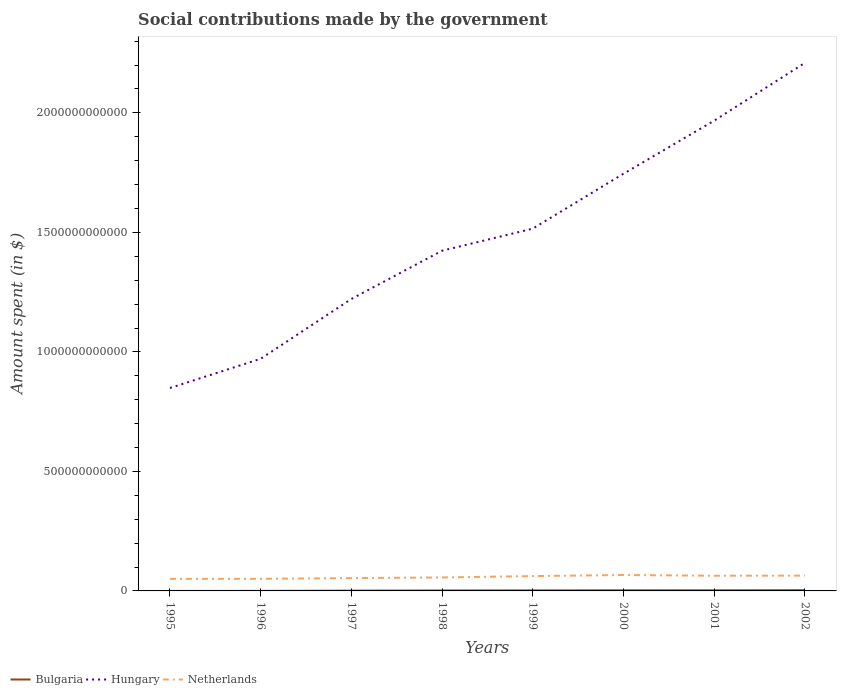How many different coloured lines are there?
Your answer should be very brief. 3. Is the number of lines equal to the number of legend labels?
Provide a succinct answer. Yes. Across all years, what is the maximum amount spent on social contributions in Netherlands?
Your response must be concise. 5.04e+1. What is the total amount spent on social contributions in Hungary in the graph?
Make the answer very short. -2.94e+11. What is the difference between the highest and the second highest amount spent on social contributions in Hungary?
Your answer should be compact. 1.36e+12. What is the difference between the highest and the lowest amount spent on social contributions in Hungary?
Your answer should be compact. 4. Is the amount spent on social contributions in Netherlands strictly greater than the amount spent on social contributions in Bulgaria over the years?
Provide a short and direct response. No. How many years are there in the graph?
Offer a very short reply. 8. What is the difference between two consecutive major ticks on the Y-axis?
Provide a short and direct response. 5.00e+11. Does the graph contain grids?
Your answer should be very brief. No. Where does the legend appear in the graph?
Give a very brief answer. Bottom left. How many legend labels are there?
Your answer should be compact. 3. How are the legend labels stacked?
Your response must be concise. Horizontal. What is the title of the graph?
Offer a very short reply. Social contributions made by the government. Does "Togo" appear as one of the legend labels in the graph?
Your answer should be compact. No. What is the label or title of the Y-axis?
Keep it short and to the point. Amount spent (in $). What is the Amount spent (in $) in Bulgaria in 1995?
Your response must be concise. 6.68e+07. What is the Amount spent (in $) of Hungary in 1995?
Your answer should be very brief. 8.49e+11. What is the Amount spent (in $) in Netherlands in 1995?
Offer a very short reply. 5.04e+1. What is the Amount spent (in $) of Bulgaria in 1996?
Make the answer very short. 1.18e+08. What is the Amount spent (in $) in Hungary in 1996?
Keep it short and to the point. 9.71e+11. What is the Amount spent (in $) in Netherlands in 1996?
Provide a succinct answer. 5.07e+1. What is the Amount spent (in $) in Bulgaria in 1997?
Offer a very short reply. 1.17e+09. What is the Amount spent (in $) of Hungary in 1997?
Make the answer very short. 1.22e+12. What is the Amount spent (in $) of Netherlands in 1997?
Make the answer very short. 5.37e+1. What is the Amount spent (in $) of Bulgaria in 1998?
Offer a terse response. 1.86e+09. What is the Amount spent (in $) of Hungary in 1998?
Make the answer very short. 1.42e+12. What is the Amount spent (in $) in Netherlands in 1998?
Your answer should be very brief. 5.63e+1. What is the Amount spent (in $) of Bulgaria in 1999?
Ensure brevity in your answer.  2.13e+09. What is the Amount spent (in $) in Hungary in 1999?
Your response must be concise. 1.52e+12. What is the Amount spent (in $) of Netherlands in 1999?
Offer a very short reply. 6.21e+1. What is the Amount spent (in $) in Bulgaria in 2000?
Ensure brevity in your answer.  2.47e+09. What is the Amount spent (in $) in Hungary in 2000?
Give a very brief answer. 1.75e+12. What is the Amount spent (in $) in Netherlands in 2000?
Your answer should be very brief. 6.66e+1. What is the Amount spent (in $) in Bulgaria in 2001?
Give a very brief answer. 2.50e+09. What is the Amount spent (in $) in Hungary in 2001?
Offer a very short reply. 1.97e+12. What is the Amount spent (in $) in Netherlands in 2001?
Provide a succinct answer. 6.36e+1. What is the Amount spent (in $) of Bulgaria in 2002?
Provide a succinct answer. 3.08e+09. What is the Amount spent (in $) of Hungary in 2002?
Offer a very short reply. 2.21e+12. What is the Amount spent (in $) in Netherlands in 2002?
Make the answer very short. 6.40e+1. Across all years, what is the maximum Amount spent (in $) in Bulgaria?
Your response must be concise. 3.08e+09. Across all years, what is the maximum Amount spent (in $) in Hungary?
Give a very brief answer. 2.21e+12. Across all years, what is the maximum Amount spent (in $) in Netherlands?
Provide a short and direct response. 6.66e+1. Across all years, what is the minimum Amount spent (in $) in Bulgaria?
Provide a short and direct response. 6.68e+07. Across all years, what is the minimum Amount spent (in $) of Hungary?
Provide a succinct answer. 8.49e+11. Across all years, what is the minimum Amount spent (in $) of Netherlands?
Provide a short and direct response. 5.04e+1. What is the total Amount spent (in $) of Bulgaria in the graph?
Provide a short and direct response. 1.34e+1. What is the total Amount spent (in $) in Hungary in the graph?
Provide a succinct answer. 1.19e+13. What is the total Amount spent (in $) in Netherlands in the graph?
Keep it short and to the point. 4.67e+11. What is the difference between the Amount spent (in $) of Bulgaria in 1995 and that in 1996?
Give a very brief answer. -5.14e+07. What is the difference between the Amount spent (in $) of Hungary in 1995 and that in 1996?
Keep it short and to the point. -1.22e+11. What is the difference between the Amount spent (in $) in Netherlands in 1995 and that in 1996?
Your response must be concise. -2.94e+08. What is the difference between the Amount spent (in $) in Bulgaria in 1995 and that in 1997?
Offer a terse response. -1.10e+09. What is the difference between the Amount spent (in $) in Hungary in 1995 and that in 1997?
Make the answer very short. -3.72e+11. What is the difference between the Amount spent (in $) of Netherlands in 1995 and that in 1997?
Give a very brief answer. -3.27e+09. What is the difference between the Amount spent (in $) of Bulgaria in 1995 and that in 1998?
Provide a succinct answer. -1.79e+09. What is the difference between the Amount spent (in $) in Hungary in 1995 and that in 1998?
Your response must be concise. -5.74e+11. What is the difference between the Amount spent (in $) in Netherlands in 1995 and that in 1998?
Your answer should be compact. -5.94e+09. What is the difference between the Amount spent (in $) in Bulgaria in 1995 and that in 1999?
Your answer should be very brief. -2.06e+09. What is the difference between the Amount spent (in $) in Hungary in 1995 and that in 1999?
Offer a terse response. -6.67e+11. What is the difference between the Amount spent (in $) in Netherlands in 1995 and that in 1999?
Your answer should be compact. -1.17e+1. What is the difference between the Amount spent (in $) of Bulgaria in 1995 and that in 2000?
Your answer should be compact. -2.40e+09. What is the difference between the Amount spent (in $) in Hungary in 1995 and that in 2000?
Provide a short and direct response. -8.96e+11. What is the difference between the Amount spent (in $) in Netherlands in 1995 and that in 2000?
Keep it short and to the point. -1.62e+1. What is the difference between the Amount spent (in $) in Bulgaria in 1995 and that in 2001?
Your response must be concise. -2.43e+09. What is the difference between the Amount spent (in $) in Hungary in 1995 and that in 2001?
Keep it short and to the point. -1.12e+12. What is the difference between the Amount spent (in $) of Netherlands in 1995 and that in 2001?
Make the answer very short. -1.32e+1. What is the difference between the Amount spent (in $) in Bulgaria in 1995 and that in 2002?
Your answer should be very brief. -3.01e+09. What is the difference between the Amount spent (in $) of Hungary in 1995 and that in 2002?
Offer a very short reply. -1.36e+12. What is the difference between the Amount spent (in $) in Netherlands in 1995 and that in 2002?
Keep it short and to the point. -1.36e+1. What is the difference between the Amount spent (in $) of Bulgaria in 1996 and that in 1997?
Your response must be concise. -1.05e+09. What is the difference between the Amount spent (in $) in Hungary in 1996 and that in 1997?
Your response must be concise. -2.50e+11. What is the difference between the Amount spent (in $) in Netherlands in 1996 and that in 1997?
Give a very brief answer. -2.98e+09. What is the difference between the Amount spent (in $) in Bulgaria in 1996 and that in 1998?
Offer a terse response. -1.74e+09. What is the difference between the Amount spent (in $) of Hungary in 1996 and that in 1998?
Give a very brief answer. -4.52e+11. What is the difference between the Amount spent (in $) in Netherlands in 1996 and that in 1998?
Make the answer very short. -5.65e+09. What is the difference between the Amount spent (in $) of Bulgaria in 1996 and that in 1999?
Your response must be concise. -2.01e+09. What is the difference between the Amount spent (in $) of Hungary in 1996 and that in 1999?
Your answer should be compact. -5.44e+11. What is the difference between the Amount spent (in $) of Netherlands in 1996 and that in 1999?
Your answer should be compact. -1.14e+1. What is the difference between the Amount spent (in $) of Bulgaria in 1996 and that in 2000?
Your response must be concise. -2.35e+09. What is the difference between the Amount spent (in $) in Hungary in 1996 and that in 2000?
Give a very brief answer. -7.74e+11. What is the difference between the Amount spent (in $) of Netherlands in 1996 and that in 2000?
Ensure brevity in your answer.  -1.59e+1. What is the difference between the Amount spent (in $) in Bulgaria in 1996 and that in 2001?
Offer a very short reply. -2.38e+09. What is the difference between the Amount spent (in $) of Hungary in 1996 and that in 2001?
Ensure brevity in your answer.  -9.96e+11. What is the difference between the Amount spent (in $) of Netherlands in 1996 and that in 2001?
Provide a succinct answer. -1.29e+1. What is the difference between the Amount spent (in $) of Bulgaria in 1996 and that in 2002?
Give a very brief answer. -2.96e+09. What is the difference between the Amount spent (in $) of Hungary in 1996 and that in 2002?
Offer a very short reply. -1.24e+12. What is the difference between the Amount spent (in $) of Netherlands in 1996 and that in 2002?
Keep it short and to the point. -1.34e+1. What is the difference between the Amount spent (in $) in Bulgaria in 1997 and that in 1998?
Provide a short and direct response. -6.85e+08. What is the difference between the Amount spent (in $) of Hungary in 1997 and that in 1998?
Your response must be concise. -2.02e+11. What is the difference between the Amount spent (in $) in Netherlands in 1997 and that in 1998?
Make the answer very short. -2.68e+09. What is the difference between the Amount spent (in $) of Bulgaria in 1997 and that in 1999?
Give a very brief answer. -9.60e+08. What is the difference between the Amount spent (in $) in Hungary in 1997 and that in 1999?
Give a very brief answer. -2.94e+11. What is the difference between the Amount spent (in $) of Netherlands in 1997 and that in 1999?
Your answer should be compact. -8.39e+09. What is the difference between the Amount spent (in $) in Bulgaria in 1997 and that in 2000?
Your response must be concise. -1.30e+09. What is the difference between the Amount spent (in $) of Hungary in 1997 and that in 2000?
Your response must be concise. -5.24e+11. What is the difference between the Amount spent (in $) in Netherlands in 1997 and that in 2000?
Make the answer very short. -1.29e+1. What is the difference between the Amount spent (in $) in Bulgaria in 1997 and that in 2001?
Keep it short and to the point. -1.33e+09. What is the difference between the Amount spent (in $) of Hungary in 1997 and that in 2001?
Ensure brevity in your answer.  -7.46e+11. What is the difference between the Amount spent (in $) of Netherlands in 1997 and that in 2001?
Provide a succinct answer. -9.90e+09. What is the difference between the Amount spent (in $) in Bulgaria in 1997 and that in 2002?
Make the answer very short. -1.90e+09. What is the difference between the Amount spent (in $) in Hungary in 1997 and that in 2002?
Your answer should be compact. -9.87e+11. What is the difference between the Amount spent (in $) of Netherlands in 1997 and that in 2002?
Keep it short and to the point. -1.04e+1. What is the difference between the Amount spent (in $) of Bulgaria in 1998 and that in 1999?
Provide a short and direct response. -2.75e+08. What is the difference between the Amount spent (in $) of Hungary in 1998 and that in 1999?
Your answer should be very brief. -9.24e+1. What is the difference between the Amount spent (in $) of Netherlands in 1998 and that in 1999?
Your answer should be very brief. -5.72e+09. What is the difference between the Amount spent (in $) of Bulgaria in 1998 and that in 2000?
Make the answer very short. -6.13e+08. What is the difference between the Amount spent (in $) of Hungary in 1998 and that in 2000?
Provide a succinct answer. -3.22e+11. What is the difference between the Amount spent (in $) in Netherlands in 1998 and that in 2000?
Make the answer very short. -1.02e+1. What is the difference between the Amount spent (in $) of Bulgaria in 1998 and that in 2001?
Your answer should be very brief. -6.42e+08. What is the difference between the Amount spent (in $) of Hungary in 1998 and that in 2001?
Keep it short and to the point. -5.44e+11. What is the difference between the Amount spent (in $) in Netherlands in 1998 and that in 2001?
Your answer should be very brief. -7.23e+09. What is the difference between the Amount spent (in $) of Bulgaria in 1998 and that in 2002?
Give a very brief answer. -1.22e+09. What is the difference between the Amount spent (in $) of Hungary in 1998 and that in 2002?
Your answer should be very brief. -7.86e+11. What is the difference between the Amount spent (in $) in Netherlands in 1998 and that in 2002?
Ensure brevity in your answer.  -7.70e+09. What is the difference between the Amount spent (in $) of Bulgaria in 1999 and that in 2000?
Your answer should be very brief. -3.37e+08. What is the difference between the Amount spent (in $) in Hungary in 1999 and that in 2000?
Make the answer very short. -2.30e+11. What is the difference between the Amount spent (in $) of Netherlands in 1999 and that in 2000?
Provide a short and direct response. -4.53e+09. What is the difference between the Amount spent (in $) of Bulgaria in 1999 and that in 2001?
Offer a very short reply. -3.66e+08. What is the difference between the Amount spent (in $) in Hungary in 1999 and that in 2001?
Your response must be concise. -4.51e+11. What is the difference between the Amount spent (in $) in Netherlands in 1999 and that in 2001?
Make the answer very short. -1.51e+09. What is the difference between the Amount spent (in $) in Bulgaria in 1999 and that in 2002?
Provide a short and direct response. -9.43e+08. What is the difference between the Amount spent (in $) in Hungary in 1999 and that in 2002?
Offer a terse response. -6.93e+11. What is the difference between the Amount spent (in $) of Netherlands in 1999 and that in 2002?
Your answer should be compact. -1.99e+09. What is the difference between the Amount spent (in $) in Bulgaria in 2000 and that in 2001?
Make the answer very short. -2.89e+07. What is the difference between the Amount spent (in $) of Hungary in 2000 and that in 2001?
Provide a succinct answer. -2.22e+11. What is the difference between the Amount spent (in $) in Netherlands in 2000 and that in 2001?
Keep it short and to the point. 3.02e+09. What is the difference between the Amount spent (in $) in Bulgaria in 2000 and that in 2002?
Your response must be concise. -6.06e+08. What is the difference between the Amount spent (in $) in Hungary in 2000 and that in 2002?
Offer a terse response. -4.64e+11. What is the difference between the Amount spent (in $) in Netherlands in 2000 and that in 2002?
Give a very brief answer. 2.55e+09. What is the difference between the Amount spent (in $) of Bulgaria in 2001 and that in 2002?
Your answer should be very brief. -5.77e+08. What is the difference between the Amount spent (in $) in Hungary in 2001 and that in 2002?
Ensure brevity in your answer.  -2.42e+11. What is the difference between the Amount spent (in $) of Netherlands in 2001 and that in 2002?
Your answer should be very brief. -4.73e+08. What is the difference between the Amount spent (in $) of Bulgaria in 1995 and the Amount spent (in $) of Hungary in 1996?
Provide a short and direct response. -9.71e+11. What is the difference between the Amount spent (in $) in Bulgaria in 1995 and the Amount spent (in $) in Netherlands in 1996?
Your response must be concise. -5.06e+1. What is the difference between the Amount spent (in $) in Hungary in 1995 and the Amount spent (in $) in Netherlands in 1996?
Your answer should be compact. 7.98e+11. What is the difference between the Amount spent (in $) in Bulgaria in 1995 and the Amount spent (in $) in Hungary in 1997?
Give a very brief answer. -1.22e+12. What is the difference between the Amount spent (in $) in Bulgaria in 1995 and the Amount spent (in $) in Netherlands in 1997?
Provide a short and direct response. -5.36e+1. What is the difference between the Amount spent (in $) of Hungary in 1995 and the Amount spent (in $) of Netherlands in 1997?
Make the answer very short. 7.95e+11. What is the difference between the Amount spent (in $) of Bulgaria in 1995 and the Amount spent (in $) of Hungary in 1998?
Your answer should be compact. -1.42e+12. What is the difference between the Amount spent (in $) in Bulgaria in 1995 and the Amount spent (in $) in Netherlands in 1998?
Your response must be concise. -5.63e+1. What is the difference between the Amount spent (in $) in Hungary in 1995 and the Amount spent (in $) in Netherlands in 1998?
Provide a succinct answer. 7.93e+11. What is the difference between the Amount spent (in $) in Bulgaria in 1995 and the Amount spent (in $) in Hungary in 1999?
Provide a succinct answer. -1.52e+12. What is the difference between the Amount spent (in $) in Bulgaria in 1995 and the Amount spent (in $) in Netherlands in 1999?
Offer a terse response. -6.20e+1. What is the difference between the Amount spent (in $) of Hungary in 1995 and the Amount spent (in $) of Netherlands in 1999?
Your answer should be very brief. 7.87e+11. What is the difference between the Amount spent (in $) in Bulgaria in 1995 and the Amount spent (in $) in Hungary in 2000?
Your response must be concise. -1.75e+12. What is the difference between the Amount spent (in $) of Bulgaria in 1995 and the Amount spent (in $) of Netherlands in 2000?
Your response must be concise. -6.65e+1. What is the difference between the Amount spent (in $) of Hungary in 1995 and the Amount spent (in $) of Netherlands in 2000?
Give a very brief answer. 7.82e+11. What is the difference between the Amount spent (in $) in Bulgaria in 1995 and the Amount spent (in $) in Hungary in 2001?
Give a very brief answer. -1.97e+12. What is the difference between the Amount spent (in $) in Bulgaria in 1995 and the Amount spent (in $) in Netherlands in 2001?
Your answer should be compact. -6.35e+1. What is the difference between the Amount spent (in $) of Hungary in 1995 and the Amount spent (in $) of Netherlands in 2001?
Keep it short and to the point. 7.85e+11. What is the difference between the Amount spent (in $) in Bulgaria in 1995 and the Amount spent (in $) in Hungary in 2002?
Provide a short and direct response. -2.21e+12. What is the difference between the Amount spent (in $) in Bulgaria in 1995 and the Amount spent (in $) in Netherlands in 2002?
Make the answer very short. -6.40e+1. What is the difference between the Amount spent (in $) of Hungary in 1995 and the Amount spent (in $) of Netherlands in 2002?
Your answer should be very brief. 7.85e+11. What is the difference between the Amount spent (in $) in Bulgaria in 1996 and the Amount spent (in $) in Hungary in 1997?
Your response must be concise. -1.22e+12. What is the difference between the Amount spent (in $) in Bulgaria in 1996 and the Amount spent (in $) in Netherlands in 1997?
Provide a succinct answer. -5.35e+1. What is the difference between the Amount spent (in $) of Hungary in 1996 and the Amount spent (in $) of Netherlands in 1997?
Give a very brief answer. 9.17e+11. What is the difference between the Amount spent (in $) in Bulgaria in 1996 and the Amount spent (in $) in Hungary in 1998?
Ensure brevity in your answer.  -1.42e+12. What is the difference between the Amount spent (in $) in Bulgaria in 1996 and the Amount spent (in $) in Netherlands in 1998?
Offer a very short reply. -5.62e+1. What is the difference between the Amount spent (in $) of Hungary in 1996 and the Amount spent (in $) of Netherlands in 1998?
Your answer should be compact. 9.15e+11. What is the difference between the Amount spent (in $) in Bulgaria in 1996 and the Amount spent (in $) in Hungary in 1999?
Your response must be concise. -1.52e+12. What is the difference between the Amount spent (in $) in Bulgaria in 1996 and the Amount spent (in $) in Netherlands in 1999?
Give a very brief answer. -6.19e+1. What is the difference between the Amount spent (in $) of Hungary in 1996 and the Amount spent (in $) of Netherlands in 1999?
Give a very brief answer. 9.09e+11. What is the difference between the Amount spent (in $) of Bulgaria in 1996 and the Amount spent (in $) of Hungary in 2000?
Your response must be concise. -1.75e+12. What is the difference between the Amount spent (in $) in Bulgaria in 1996 and the Amount spent (in $) in Netherlands in 2000?
Your response must be concise. -6.65e+1. What is the difference between the Amount spent (in $) in Hungary in 1996 and the Amount spent (in $) in Netherlands in 2000?
Provide a short and direct response. 9.05e+11. What is the difference between the Amount spent (in $) of Bulgaria in 1996 and the Amount spent (in $) of Hungary in 2001?
Offer a very short reply. -1.97e+12. What is the difference between the Amount spent (in $) of Bulgaria in 1996 and the Amount spent (in $) of Netherlands in 2001?
Offer a terse response. -6.35e+1. What is the difference between the Amount spent (in $) of Hungary in 1996 and the Amount spent (in $) of Netherlands in 2001?
Offer a very short reply. 9.08e+11. What is the difference between the Amount spent (in $) of Bulgaria in 1996 and the Amount spent (in $) of Hungary in 2002?
Your response must be concise. -2.21e+12. What is the difference between the Amount spent (in $) of Bulgaria in 1996 and the Amount spent (in $) of Netherlands in 2002?
Your response must be concise. -6.39e+1. What is the difference between the Amount spent (in $) of Hungary in 1996 and the Amount spent (in $) of Netherlands in 2002?
Provide a succinct answer. 9.07e+11. What is the difference between the Amount spent (in $) in Bulgaria in 1997 and the Amount spent (in $) in Hungary in 1998?
Provide a succinct answer. -1.42e+12. What is the difference between the Amount spent (in $) of Bulgaria in 1997 and the Amount spent (in $) of Netherlands in 1998?
Give a very brief answer. -5.52e+1. What is the difference between the Amount spent (in $) in Hungary in 1997 and the Amount spent (in $) in Netherlands in 1998?
Offer a terse response. 1.17e+12. What is the difference between the Amount spent (in $) in Bulgaria in 1997 and the Amount spent (in $) in Hungary in 1999?
Give a very brief answer. -1.51e+12. What is the difference between the Amount spent (in $) in Bulgaria in 1997 and the Amount spent (in $) in Netherlands in 1999?
Your response must be concise. -6.09e+1. What is the difference between the Amount spent (in $) of Hungary in 1997 and the Amount spent (in $) of Netherlands in 1999?
Your answer should be compact. 1.16e+12. What is the difference between the Amount spent (in $) in Bulgaria in 1997 and the Amount spent (in $) in Hungary in 2000?
Provide a short and direct response. -1.74e+12. What is the difference between the Amount spent (in $) in Bulgaria in 1997 and the Amount spent (in $) in Netherlands in 2000?
Offer a terse response. -6.54e+1. What is the difference between the Amount spent (in $) of Hungary in 1997 and the Amount spent (in $) of Netherlands in 2000?
Make the answer very short. 1.15e+12. What is the difference between the Amount spent (in $) in Bulgaria in 1997 and the Amount spent (in $) in Hungary in 2001?
Offer a terse response. -1.97e+12. What is the difference between the Amount spent (in $) of Bulgaria in 1997 and the Amount spent (in $) of Netherlands in 2001?
Offer a terse response. -6.24e+1. What is the difference between the Amount spent (in $) of Hungary in 1997 and the Amount spent (in $) of Netherlands in 2001?
Provide a succinct answer. 1.16e+12. What is the difference between the Amount spent (in $) of Bulgaria in 1997 and the Amount spent (in $) of Hungary in 2002?
Ensure brevity in your answer.  -2.21e+12. What is the difference between the Amount spent (in $) in Bulgaria in 1997 and the Amount spent (in $) in Netherlands in 2002?
Offer a terse response. -6.29e+1. What is the difference between the Amount spent (in $) in Hungary in 1997 and the Amount spent (in $) in Netherlands in 2002?
Make the answer very short. 1.16e+12. What is the difference between the Amount spent (in $) of Bulgaria in 1998 and the Amount spent (in $) of Hungary in 1999?
Make the answer very short. -1.51e+12. What is the difference between the Amount spent (in $) in Bulgaria in 1998 and the Amount spent (in $) in Netherlands in 1999?
Make the answer very short. -6.02e+1. What is the difference between the Amount spent (in $) in Hungary in 1998 and the Amount spent (in $) in Netherlands in 1999?
Your response must be concise. 1.36e+12. What is the difference between the Amount spent (in $) of Bulgaria in 1998 and the Amount spent (in $) of Hungary in 2000?
Your response must be concise. -1.74e+12. What is the difference between the Amount spent (in $) in Bulgaria in 1998 and the Amount spent (in $) in Netherlands in 2000?
Your answer should be compact. -6.47e+1. What is the difference between the Amount spent (in $) in Hungary in 1998 and the Amount spent (in $) in Netherlands in 2000?
Provide a succinct answer. 1.36e+12. What is the difference between the Amount spent (in $) of Bulgaria in 1998 and the Amount spent (in $) of Hungary in 2001?
Provide a short and direct response. -1.97e+12. What is the difference between the Amount spent (in $) in Bulgaria in 1998 and the Amount spent (in $) in Netherlands in 2001?
Make the answer very short. -6.17e+1. What is the difference between the Amount spent (in $) in Hungary in 1998 and the Amount spent (in $) in Netherlands in 2001?
Give a very brief answer. 1.36e+12. What is the difference between the Amount spent (in $) of Bulgaria in 1998 and the Amount spent (in $) of Hungary in 2002?
Ensure brevity in your answer.  -2.21e+12. What is the difference between the Amount spent (in $) of Bulgaria in 1998 and the Amount spent (in $) of Netherlands in 2002?
Offer a terse response. -6.22e+1. What is the difference between the Amount spent (in $) in Hungary in 1998 and the Amount spent (in $) in Netherlands in 2002?
Your answer should be compact. 1.36e+12. What is the difference between the Amount spent (in $) of Bulgaria in 1999 and the Amount spent (in $) of Hungary in 2000?
Ensure brevity in your answer.  -1.74e+12. What is the difference between the Amount spent (in $) in Bulgaria in 1999 and the Amount spent (in $) in Netherlands in 2000?
Offer a terse response. -6.45e+1. What is the difference between the Amount spent (in $) of Hungary in 1999 and the Amount spent (in $) of Netherlands in 2000?
Provide a succinct answer. 1.45e+12. What is the difference between the Amount spent (in $) of Bulgaria in 1999 and the Amount spent (in $) of Hungary in 2001?
Give a very brief answer. -1.96e+12. What is the difference between the Amount spent (in $) of Bulgaria in 1999 and the Amount spent (in $) of Netherlands in 2001?
Provide a short and direct response. -6.14e+1. What is the difference between the Amount spent (in $) of Hungary in 1999 and the Amount spent (in $) of Netherlands in 2001?
Your response must be concise. 1.45e+12. What is the difference between the Amount spent (in $) in Bulgaria in 1999 and the Amount spent (in $) in Hungary in 2002?
Your answer should be compact. -2.21e+12. What is the difference between the Amount spent (in $) of Bulgaria in 1999 and the Amount spent (in $) of Netherlands in 2002?
Provide a succinct answer. -6.19e+1. What is the difference between the Amount spent (in $) in Hungary in 1999 and the Amount spent (in $) in Netherlands in 2002?
Ensure brevity in your answer.  1.45e+12. What is the difference between the Amount spent (in $) in Bulgaria in 2000 and the Amount spent (in $) in Hungary in 2001?
Your response must be concise. -1.96e+12. What is the difference between the Amount spent (in $) in Bulgaria in 2000 and the Amount spent (in $) in Netherlands in 2001?
Make the answer very short. -6.11e+1. What is the difference between the Amount spent (in $) in Hungary in 2000 and the Amount spent (in $) in Netherlands in 2001?
Offer a very short reply. 1.68e+12. What is the difference between the Amount spent (in $) of Bulgaria in 2000 and the Amount spent (in $) of Hungary in 2002?
Give a very brief answer. -2.21e+12. What is the difference between the Amount spent (in $) in Bulgaria in 2000 and the Amount spent (in $) in Netherlands in 2002?
Provide a short and direct response. -6.16e+1. What is the difference between the Amount spent (in $) of Hungary in 2000 and the Amount spent (in $) of Netherlands in 2002?
Give a very brief answer. 1.68e+12. What is the difference between the Amount spent (in $) of Bulgaria in 2001 and the Amount spent (in $) of Hungary in 2002?
Offer a terse response. -2.21e+12. What is the difference between the Amount spent (in $) in Bulgaria in 2001 and the Amount spent (in $) in Netherlands in 2002?
Your answer should be very brief. -6.15e+1. What is the difference between the Amount spent (in $) in Hungary in 2001 and the Amount spent (in $) in Netherlands in 2002?
Keep it short and to the point. 1.90e+12. What is the average Amount spent (in $) in Bulgaria per year?
Your answer should be compact. 1.67e+09. What is the average Amount spent (in $) in Hungary per year?
Make the answer very short. 1.49e+12. What is the average Amount spent (in $) of Netherlands per year?
Keep it short and to the point. 5.84e+1. In the year 1995, what is the difference between the Amount spent (in $) of Bulgaria and Amount spent (in $) of Hungary?
Your answer should be compact. -8.49e+11. In the year 1995, what is the difference between the Amount spent (in $) in Bulgaria and Amount spent (in $) in Netherlands?
Ensure brevity in your answer.  -5.03e+1. In the year 1995, what is the difference between the Amount spent (in $) in Hungary and Amount spent (in $) in Netherlands?
Provide a succinct answer. 7.99e+11. In the year 1996, what is the difference between the Amount spent (in $) in Bulgaria and Amount spent (in $) in Hungary?
Your answer should be compact. -9.71e+11. In the year 1996, what is the difference between the Amount spent (in $) of Bulgaria and Amount spent (in $) of Netherlands?
Your response must be concise. -5.06e+1. In the year 1996, what is the difference between the Amount spent (in $) of Hungary and Amount spent (in $) of Netherlands?
Provide a short and direct response. 9.20e+11. In the year 1997, what is the difference between the Amount spent (in $) in Bulgaria and Amount spent (in $) in Hungary?
Make the answer very short. -1.22e+12. In the year 1997, what is the difference between the Amount spent (in $) in Bulgaria and Amount spent (in $) in Netherlands?
Your answer should be compact. -5.25e+1. In the year 1997, what is the difference between the Amount spent (in $) in Hungary and Amount spent (in $) in Netherlands?
Ensure brevity in your answer.  1.17e+12. In the year 1998, what is the difference between the Amount spent (in $) of Bulgaria and Amount spent (in $) of Hungary?
Your answer should be very brief. -1.42e+12. In the year 1998, what is the difference between the Amount spent (in $) in Bulgaria and Amount spent (in $) in Netherlands?
Provide a succinct answer. -5.45e+1. In the year 1998, what is the difference between the Amount spent (in $) of Hungary and Amount spent (in $) of Netherlands?
Give a very brief answer. 1.37e+12. In the year 1999, what is the difference between the Amount spent (in $) of Bulgaria and Amount spent (in $) of Hungary?
Give a very brief answer. -1.51e+12. In the year 1999, what is the difference between the Amount spent (in $) in Bulgaria and Amount spent (in $) in Netherlands?
Your answer should be compact. -5.99e+1. In the year 1999, what is the difference between the Amount spent (in $) in Hungary and Amount spent (in $) in Netherlands?
Provide a short and direct response. 1.45e+12. In the year 2000, what is the difference between the Amount spent (in $) in Bulgaria and Amount spent (in $) in Hungary?
Ensure brevity in your answer.  -1.74e+12. In the year 2000, what is the difference between the Amount spent (in $) of Bulgaria and Amount spent (in $) of Netherlands?
Keep it short and to the point. -6.41e+1. In the year 2000, what is the difference between the Amount spent (in $) in Hungary and Amount spent (in $) in Netherlands?
Your response must be concise. 1.68e+12. In the year 2001, what is the difference between the Amount spent (in $) of Bulgaria and Amount spent (in $) of Hungary?
Keep it short and to the point. -1.96e+12. In the year 2001, what is the difference between the Amount spent (in $) in Bulgaria and Amount spent (in $) in Netherlands?
Provide a short and direct response. -6.11e+1. In the year 2001, what is the difference between the Amount spent (in $) in Hungary and Amount spent (in $) in Netherlands?
Your answer should be very brief. 1.90e+12. In the year 2002, what is the difference between the Amount spent (in $) in Bulgaria and Amount spent (in $) in Hungary?
Give a very brief answer. -2.21e+12. In the year 2002, what is the difference between the Amount spent (in $) in Bulgaria and Amount spent (in $) in Netherlands?
Make the answer very short. -6.10e+1. In the year 2002, what is the difference between the Amount spent (in $) in Hungary and Amount spent (in $) in Netherlands?
Your answer should be compact. 2.14e+12. What is the ratio of the Amount spent (in $) of Bulgaria in 1995 to that in 1996?
Provide a succinct answer. 0.57. What is the ratio of the Amount spent (in $) of Hungary in 1995 to that in 1996?
Offer a very short reply. 0.87. What is the ratio of the Amount spent (in $) in Netherlands in 1995 to that in 1996?
Your response must be concise. 0.99. What is the ratio of the Amount spent (in $) of Bulgaria in 1995 to that in 1997?
Provide a succinct answer. 0.06. What is the ratio of the Amount spent (in $) of Hungary in 1995 to that in 1997?
Your response must be concise. 0.7. What is the ratio of the Amount spent (in $) in Netherlands in 1995 to that in 1997?
Offer a very short reply. 0.94. What is the ratio of the Amount spent (in $) of Bulgaria in 1995 to that in 1998?
Keep it short and to the point. 0.04. What is the ratio of the Amount spent (in $) of Hungary in 1995 to that in 1998?
Ensure brevity in your answer.  0.6. What is the ratio of the Amount spent (in $) of Netherlands in 1995 to that in 1998?
Offer a very short reply. 0.89. What is the ratio of the Amount spent (in $) in Bulgaria in 1995 to that in 1999?
Keep it short and to the point. 0.03. What is the ratio of the Amount spent (in $) of Hungary in 1995 to that in 1999?
Provide a succinct answer. 0.56. What is the ratio of the Amount spent (in $) of Netherlands in 1995 to that in 1999?
Ensure brevity in your answer.  0.81. What is the ratio of the Amount spent (in $) of Bulgaria in 1995 to that in 2000?
Offer a very short reply. 0.03. What is the ratio of the Amount spent (in $) in Hungary in 1995 to that in 2000?
Provide a short and direct response. 0.49. What is the ratio of the Amount spent (in $) in Netherlands in 1995 to that in 2000?
Provide a short and direct response. 0.76. What is the ratio of the Amount spent (in $) of Bulgaria in 1995 to that in 2001?
Provide a short and direct response. 0.03. What is the ratio of the Amount spent (in $) of Hungary in 1995 to that in 2001?
Keep it short and to the point. 0.43. What is the ratio of the Amount spent (in $) of Netherlands in 1995 to that in 2001?
Keep it short and to the point. 0.79. What is the ratio of the Amount spent (in $) of Bulgaria in 1995 to that in 2002?
Make the answer very short. 0.02. What is the ratio of the Amount spent (in $) in Hungary in 1995 to that in 2002?
Your response must be concise. 0.38. What is the ratio of the Amount spent (in $) of Netherlands in 1995 to that in 2002?
Offer a terse response. 0.79. What is the ratio of the Amount spent (in $) in Bulgaria in 1996 to that in 1997?
Give a very brief answer. 0.1. What is the ratio of the Amount spent (in $) of Hungary in 1996 to that in 1997?
Provide a succinct answer. 0.8. What is the ratio of the Amount spent (in $) in Netherlands in 1996 to that in 1997?
Ensure brevity in your answer.  0.94. What is the ratio of the Amount spent (in $) of Bulgaria in 1996 to that in 1998?
Provide a succinct answer. 0.06. What is the ratio of the Amount spent (in $) of Hungary in 1996 to that in 1998?
Offer a very short reply. 0.68. What is the ratio of the Amount spent (in $) of Netherlands in 1996 to that in 1998?
Make the answer very short. 0.9. What is the ratio of the Amount spent (in $) of Bulgaria in 1996 to that in 1999?
Your answer should be very brief. 0.06. What is the ratio of the Amount spent (in $) in Hungary in 1996 to that in 1999?
Offer a terse response. 0.64. What is the ratio of the Amount spent (in $) of Netherlands in 1996 to that in 1999?
Offer a terse response. 0.82. What is the ratio of the Amount spent (in $) of Bulgaria in 1996 to that in 2000?
Provide a short and direct response. 0.05. What is the ratio of the Amount spent (in $) of Hungary in 1996 to that in 2000?
Provide a succinct answer. 0.56. What is the ratio of the Amount spent (in $) in Netherlands in 1996 to that in 2000?
Make the answer very short. 0.76. What is the ratio of the Amount spent (in $) of Bulgaria in 1996 to that in 2001?
Offer a very short reply. 0.05. What is the ratio of the Amount spent (in $) in Hungary in 1996 to that in 2001?
Your answer should be compact. 0.49. What is the ratio of the Amount spent (in $) in Netherlands in 1996 to that in 2001?
Your response must be concise. 0.8. What is the ratio of the Amount spent (in $) of Bulgaria in 1996 to that in 2002?
Provide a short and direct response. 0.04. What is the ratio of the Amount spent (in $) in Hungary in 1996 to that in 2002?
Offer a very short reply. 0.44. What is the ratio of the Amount spent (in $) in Netherlands in 1996 to that in 2002?
Make the answer very short. 0.79. What is the ratio of the Amount spent (in $) in Bulgaria in 1997 to that in 1998?
Ensure brevity in your answer.  0.63. What is the ratio of the Amount spent (in $) of Hungary in 1997 to that in 1998?
Your answer should be very brief. 0.86. What is the ratio of the Amount spent (in $) of Netherlands in 1997 to that in 1998?
Give a very brief answer. 0.95. What is the ratio of the Amount spent (in $) of Bulgaria in 1997 to that in 1999?
Your answer should be very brief. 0.55. What is the ratio of the Amount spent (in $) in Hungary in 1997 to that in 1999?
Your response must be concise. 0.81. What is the ratio of the Amount spent (in $) of Netherlands in 1997 to that in 1999?
Offer a very short reply. 0.86. What is the ratio of the Amount spent (in $) in Bulgaria in 1997 to that in 2000?
Your response must be concise. 0.47. What is the ratio of the Amount spent (in $) of Hungary in 1997 to that in 2000?
Ensure brevity in your answer.  0.7. What is the ratio of the Amount spent (in $) of Netherlands in 1997 to that in 2000?
Offer a very short reply. 0.81. What is the ratio of the Amount spent (in $) in Bulgaria in 1997 to that in 2001?
Your answer should be very brief. 0.47. What is the ratio of the Amount spent (in $) of Hungary in 1997 to that in 2001?
Give a very brief answer. 0.62. What is the ratio of the Amount spent (in $) of Netherlands in 1997 to that in 2001?
Offer a very short reply. 0.84. What is the ratio of the Amount spent (in $) of Bulgaria in 1997 to that in 2002?
Provide a succinct answer. 0.38. What is the ratio of the Amount spent (in $) of Hungary in 1997 to that in 2002?
Make the answer very short. 0.55. What is the ratio of the Amount spent (in $) in Netherlands in 1997 to that in 2002?
Give a very brief answer. 0.84. What is the ratio of the Amount spent (in $) of Bulgaria in 1998 to that in 1999?
Make the answer very short. 0.87. What is the ratio of the Amount spent (in $) of Hungary in 1998 to that in 1999?
Your response must be concise. 0.94. What is the ratio of the Amount spent (in $) of Netherlands in 1998 to that in 1999?
Ensure brevity in your answer.  0.91. What is the ratio of the Amount spent (in $) in Bulgaria in 1998 to that in 2000?
Offer a very short reply. 0.75. What is the ratio of the Amount spent (in $) of Hungary in 1998 to that in 2000?
Offer a very short reply. 0.82. What is the ratio of the Amount spent (in $) of Netherlands in 1998 to that in 2000?
Make the answer very short. 0.85. What is the ratio of the Amount spent (in $) of Bulgaria in 1998 to that in 2001?
Offer a terse response. 0.74. What is the ratio of the Amount spent (in $) in Hungary in 1998 to that in 2001?
Offer a very short reply. 0.72. What is the ratio of the Amount spent (in $) in Netherlands in 1998 to that in 2001?
Your answer should be very brief. 0.89. What is the ratio of the Amount spent (in $) of Bulgaria in 1998 to that in 2002?
Offer a terse response. 0.6. What is the ratio of the Amount spent (in $) in Hungary in 1998 to that in 2002?
Your answer should be very brief. 0.64. What is the ratio of the Amount spent (in $) of Netherlands in 1998 to that in 2002?
Your answer should be very brief. 0.88. What is the ratio of the Amount spent (in $) of Bulgaria in 1999 to that in 2000?
Provide a short and direct response. 0.86. What is the ratio of the Amount spent (in $) of Hungary in 1999 to that in 2000?
Offer a very short reply. 0.87. What is the ratio of the Amount spent (in $) of Netherlands in 1999 to that in 2000?
Your answer should be very brief. 0.93. What is the ratio of the Amount spent (in $) of Bulgaria in 1999 to that in 2001?
Keep it short and to the point. 0.85. What is the ratio of the Amount spent (in $) in Hungary in 1999 to that in 2001?
Keep it short and to the point. 0.77. What is the ratio of the Amount spent (in $) in Netherlands in 1999 to that in 2001?
Make the answer very short. 0.98. What is the ratio of the Amount spent (in $) in Bulgaria in 1999 to that in 2002?
Your answer should be very brief. 0.69. What is the ratio of the Amount spent (in $) in Hungary in 1999 to that in 2002?
Your response must be concise. 0.69. What is the ratio of the Amount spent (in $) in Bulgaria in 2000 to that in 2001?
Provide a succinct answer. 0.99. What is the ratio of the Amount spent (in $) of Hungary in 2000 to that in 2001?
Your response must be concise. 0.89. What is the ratio of the Amount spent (in $) in Netherlands in 2000 to that in 2001?
Make the answer very short. 1.05. What is the ratio of the Amount spent (in $) in Bulgaria in 2000 to that in 2002?
Offer a very short reply. 0.8. What is the ratio of the Amount spent (in $) in Hungary in 2000 to that in 2002?
Your answer should be compact. 0.79. What is the ratio of the Amount spent (in $) of Netherlands in 2000 to that in 2002?
Ensure brevity in your answer.  1.04. What is the ratio of the Amount spent (in $) of Bulgaria in 2001 to that in 2002?
Ensure brevity in your answer.  0.81. What is the ratio of the Amount spent (in $) in Hungary in 2001 to that in 2002?
Your answer should be very brief. 0.89. What is the difference between the highest and the second highest Amount spent (in $) of Bulgaria?
Make the answer very short. 5.77e+08. What is the difference between the highest and the second highest Amount spent (in $) in Hungary?
Keep it short and to the point. 2.42e+11. What is the difference between the highest and the second highest Amount spent (in $) in Netherlands?
Your answer should be very brief. 2.55e+09. What is the difference between the highest and the lowest Amount spent (in $) of Bulgaria?
Keep it short and to the point. 3.01e+09. What is the difference between the highest and the lowest Amount spent (in $) in Hungary?
Make the answer very short. 1.36e+12. What is the difference between the highest and the lowest Amount spent (in $) in Netherlands?
Your answer should be very brief. 1.62e+1. 